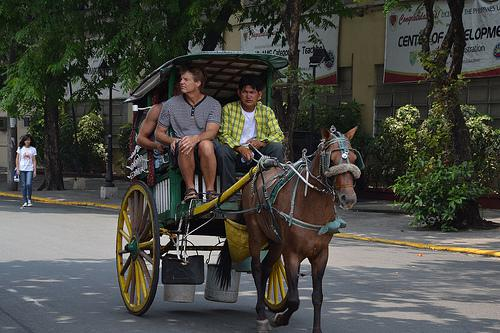Question: who is holding the reins?
Choices:
A. The carraige driver.
B. The man in a yellow shirt.
C. The jockey.
D. The girl in black.
Answer with the letter. Answer: B Question: how is the weather?
Choices:
A. Overcast.
B. Stormy.
C. Sunny.
D. Snowy.
Answer with the letter. Answer: C Question: where was this picture taken?
Choices:
A. The beach.
B. The mountain.
C. A street.
D. The lake.
Answer with the letter. Answer: C Question: what is in the picture?
Choices:
A. A baby.
B. A car.
C. An airplane.
D. A horse and carriage.
Answer with the letter. Answer: D Question: who is in the picture?
Choices:
A. Three men.
B. A family.
C. Three workers.
D. A ball team.
Answer with the letter. Answer: A 